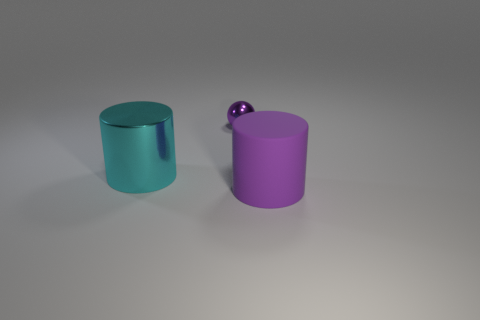Do the objects appear to be made of the same material, and can you determine their textures? While the objects share similar cylindrical shapes, their textures are different. The smaller purple sphere and the larger purple cylinder exhibit a smooth, matte texture, lacking reflectivity. In contrast, the turquoise cylinder has a more reflective surface, indicating a material that is less matte, perhaps with a satin finish. 